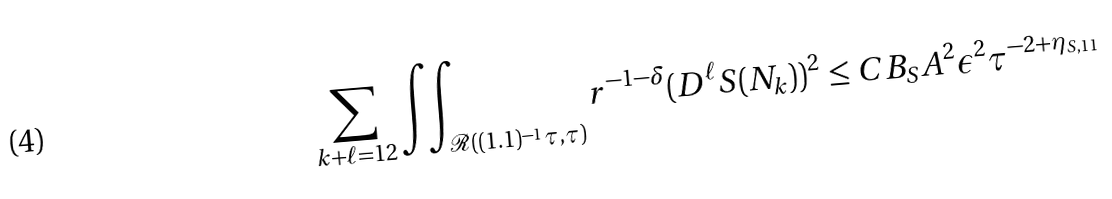<formula> <loc_0><loc_0><loc_500><loc_500>\sum _ { k + \ell = 1 2 } \iint _ { \mathcal { R } ( ( 1 . 1 ) ^ { - 1 } \tau , \tau ) } r ^ { - 1 - \delta } ( D ^ { \ell } S ( N _ { k } ) ) ^ { 2 } \leq C B _ { S } A ^ { 2 } \epsilon ^ { 2 } \tau ^ { - 2 + \eta _ { S , 1 1 } }</formula> 